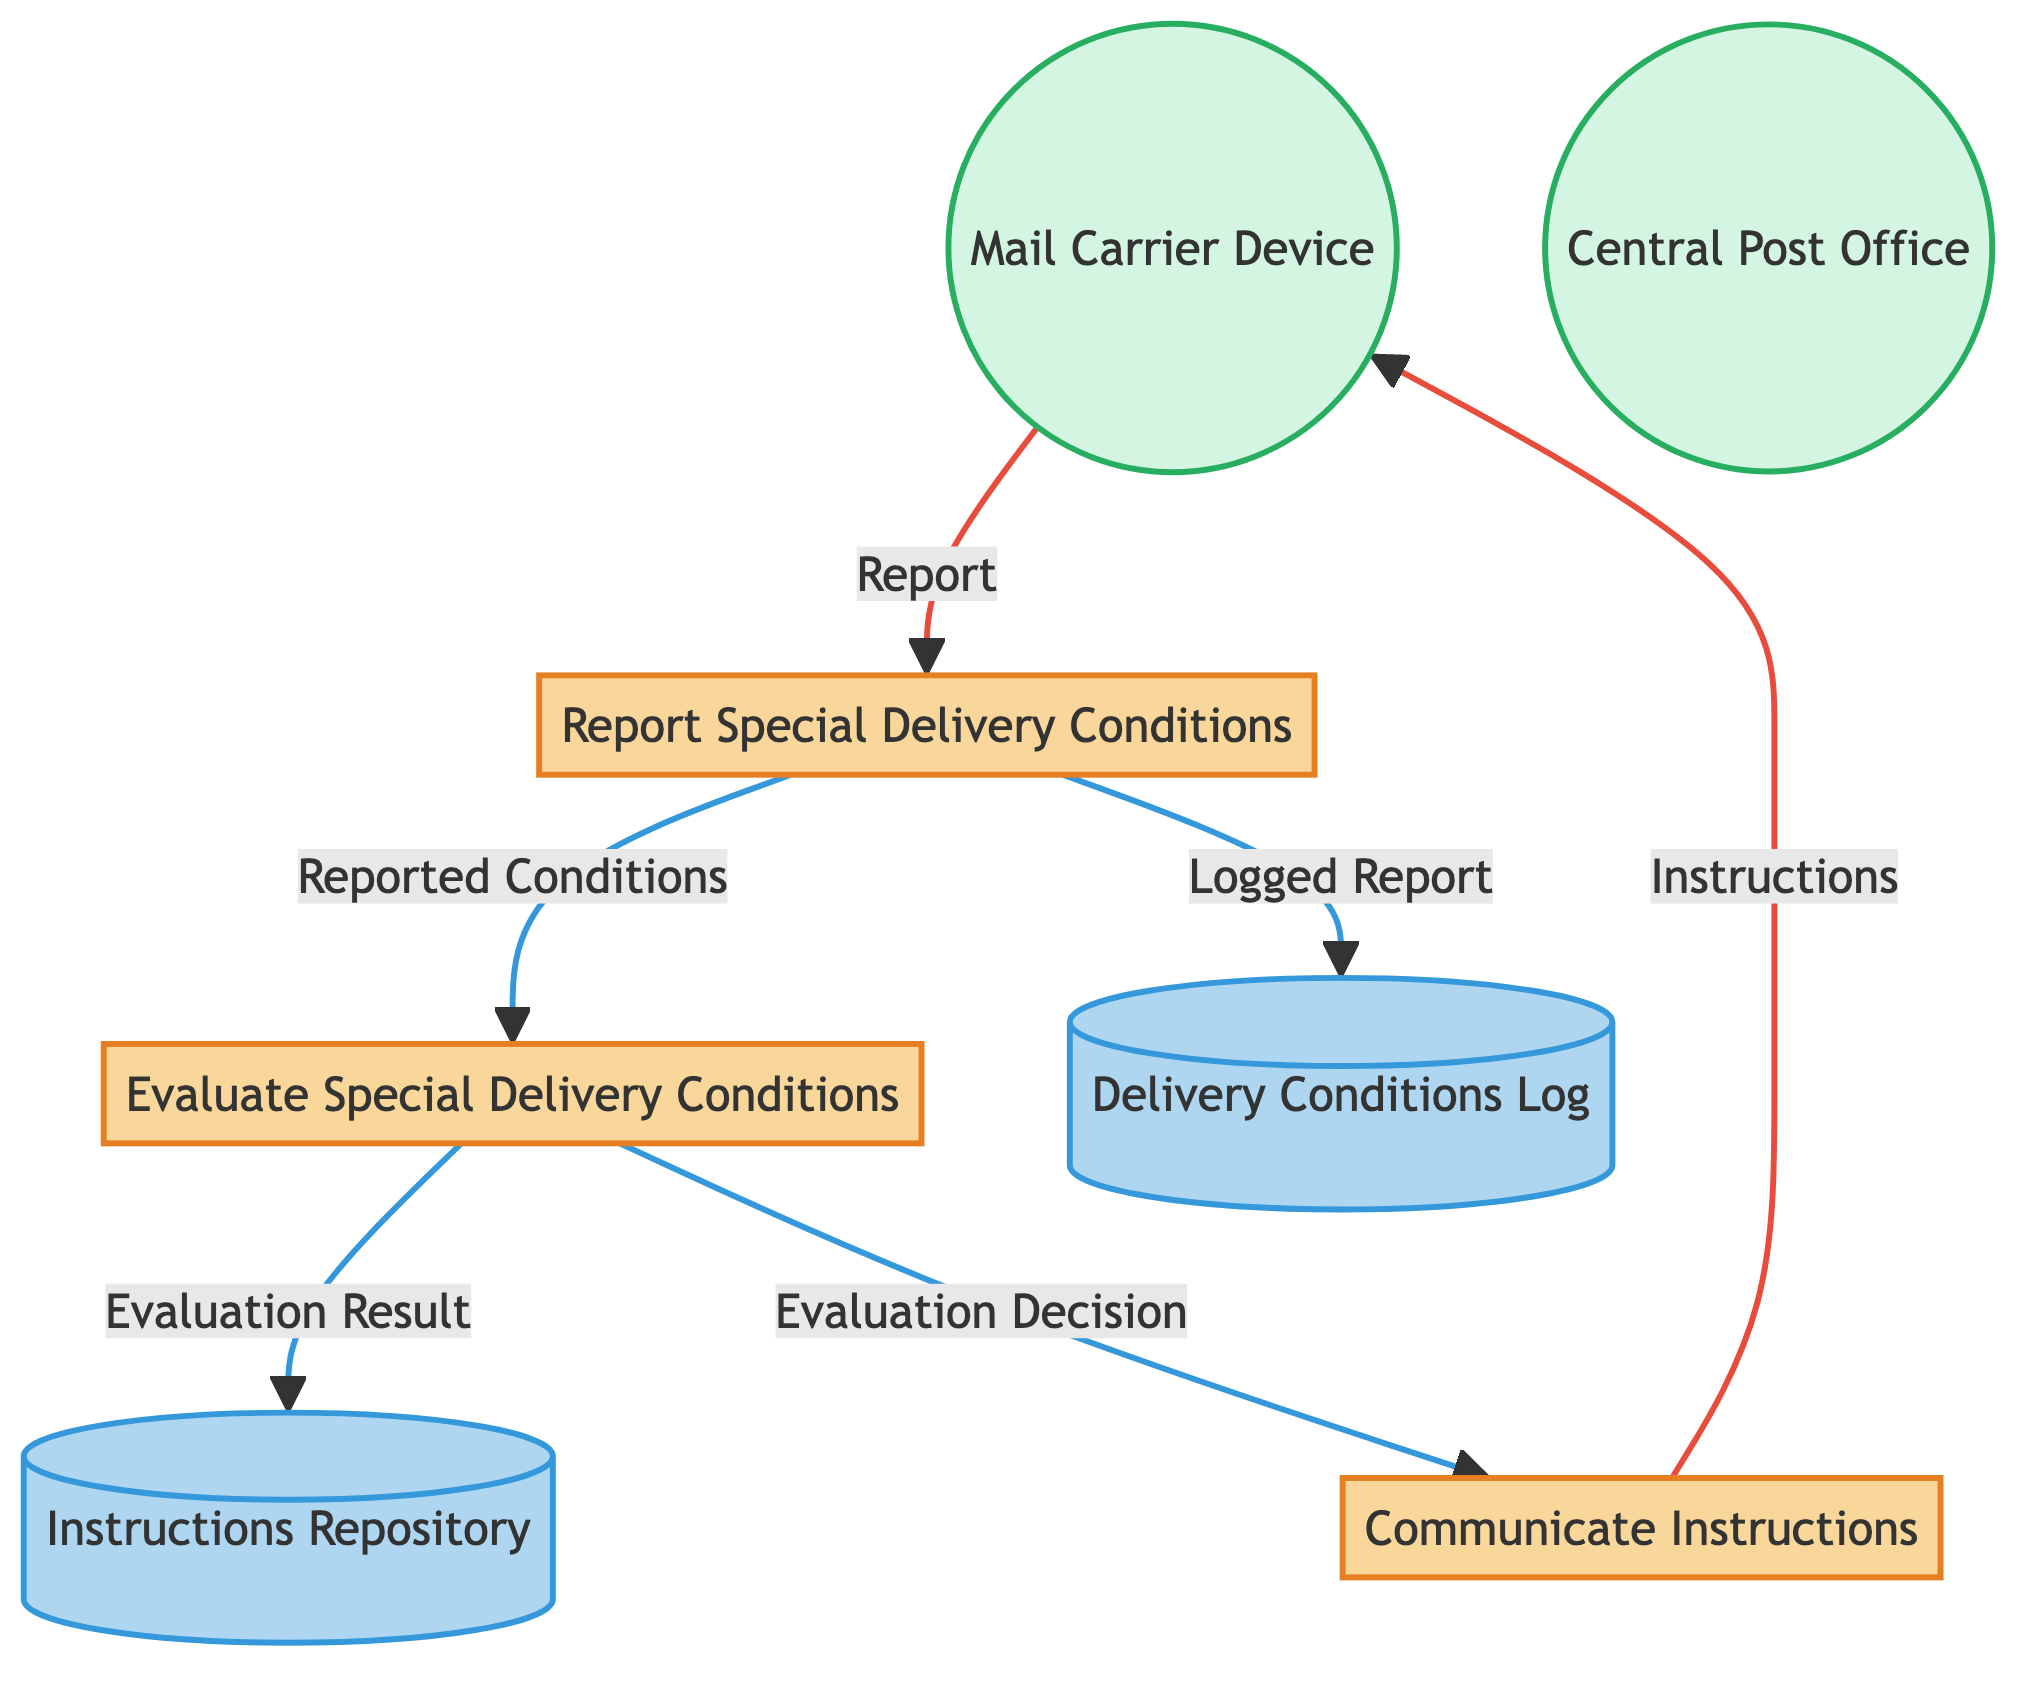What are the names of the processes in the diagram? The diagram lists three processes: "Report Special Delivery Conditions," "Evaluate Special Delivery Conditions," and "Communicate Instructions." Each represents a distinct step in the communication and evaluation flow.
Answer: Report Special Delivery Conditions, Evaluate Special Delivery Conditions, Communicate Instructions How many data stores are present in the diagram? The diagram includes two data stores: "Delivery Conditions Log" and "Instructions Repository." These stores hold important information related to special delivery conditions and instructions.
Answer: 2 What is the source of the "Evaluation Decision"? The "Evaluation Decision" is linked to the process "Evaluate Special Delivery Conditions." This indicates that the decision regarding reported special delivery conditions originates from this evaluation process.
Answer: Evaluate Special Delivery Conditions Which external entity communicates with the "Report Special Delivery Conditions" process? The external entity that interacts with the "Report Special Delivery Conditions" process is the "MailCarrierDevice." This entity represents the mail carrier's mobile device responsible for sending reports.
Answer: MailCarrierDevice How does the "Instructions" reach the mail carrier's device? "Instructions" flow from the "Communicate Instructions" process to the "MailCarrierDevice," signifying that the post office's communication supplies the mail carrier with the necessary guidance based on evaluated conditions.
Answer: Communicate Instructions What happens after "Report Special Delivery Conditions" sends the "Reported Conditions"? After sending the "Reported Conditions" to "Evaluate Special Delivery Conditions," the central post office assesses the conditions and may either communicate specific instructions back or record the evaluation results for future reference.
Answer: Communicate Instructions, Delivery Conditions Log What is stored in the "Instructions Repository"? The "Instructions Repository" stores the results of the analysis of reported special delivery conditions and the related instructions generated from the evaluation process. This repository serves as a central location for reference.
Answer: Evaluation Result What action is prompted by "Evaluate Special Delivery Conditions"? The action prompted is the "Communicate Instructions" process, which deals with sending necessary instructions derived from evaluating reported delivery conditions back to the mail carrier's device.
Answer: Communicate Instructions What is the purpose of the "Delivery Conditions Log"? The purpose of the "Delivery Conditions Log" is to formally document the special delivery conditions reported by the mail carrier. This log ensures that all past reports and relevant actions are recorded for tracking and assessment purposes.
Answer: To record special delivery conditions 